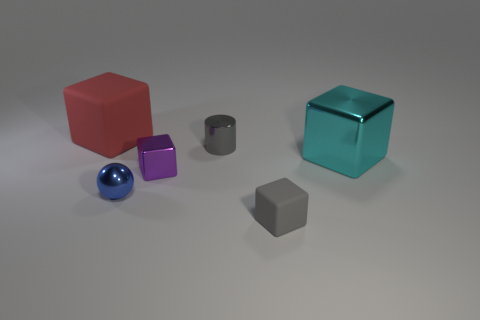What material is the large cube that is to the left of the large thing that is in front of the matte object that is behind the small matte thing?
Offer a very short reply. Rubber. Do the blue metallic object and the rubber thing in front of the large matte block have the same size?
Offer a terse response. Yes. What number of objects are either metallic things that are in front of the big cyan metal cube or objects on the left side of the tiny cylinder?
Make the answer very short. 3. What color is the big cube left of the gray cube?
Your answer should be very brief. Red. There is a block behind the large metallic block; is there a purple metal cube on the left side of it?
Offer a very short reply. No. Is the number of big rubber things less than the number of rubber blocks?
Provide a short and direct response. Yes. What is the material of the big block that is right of the tiny object that is behind the purple shiny thing?
Your answer should be very brief. Metal. Do the cyan metallic block and the metallic sphere have the same size?
Give a very brief answer. No. How many objects are small shiny objects or blue things?
Offer a terse response. 3. There is a thing that is both in front of the purple cube and behind the tiny gray matte block; what is its size?
Provide a succinct answer. Small. 